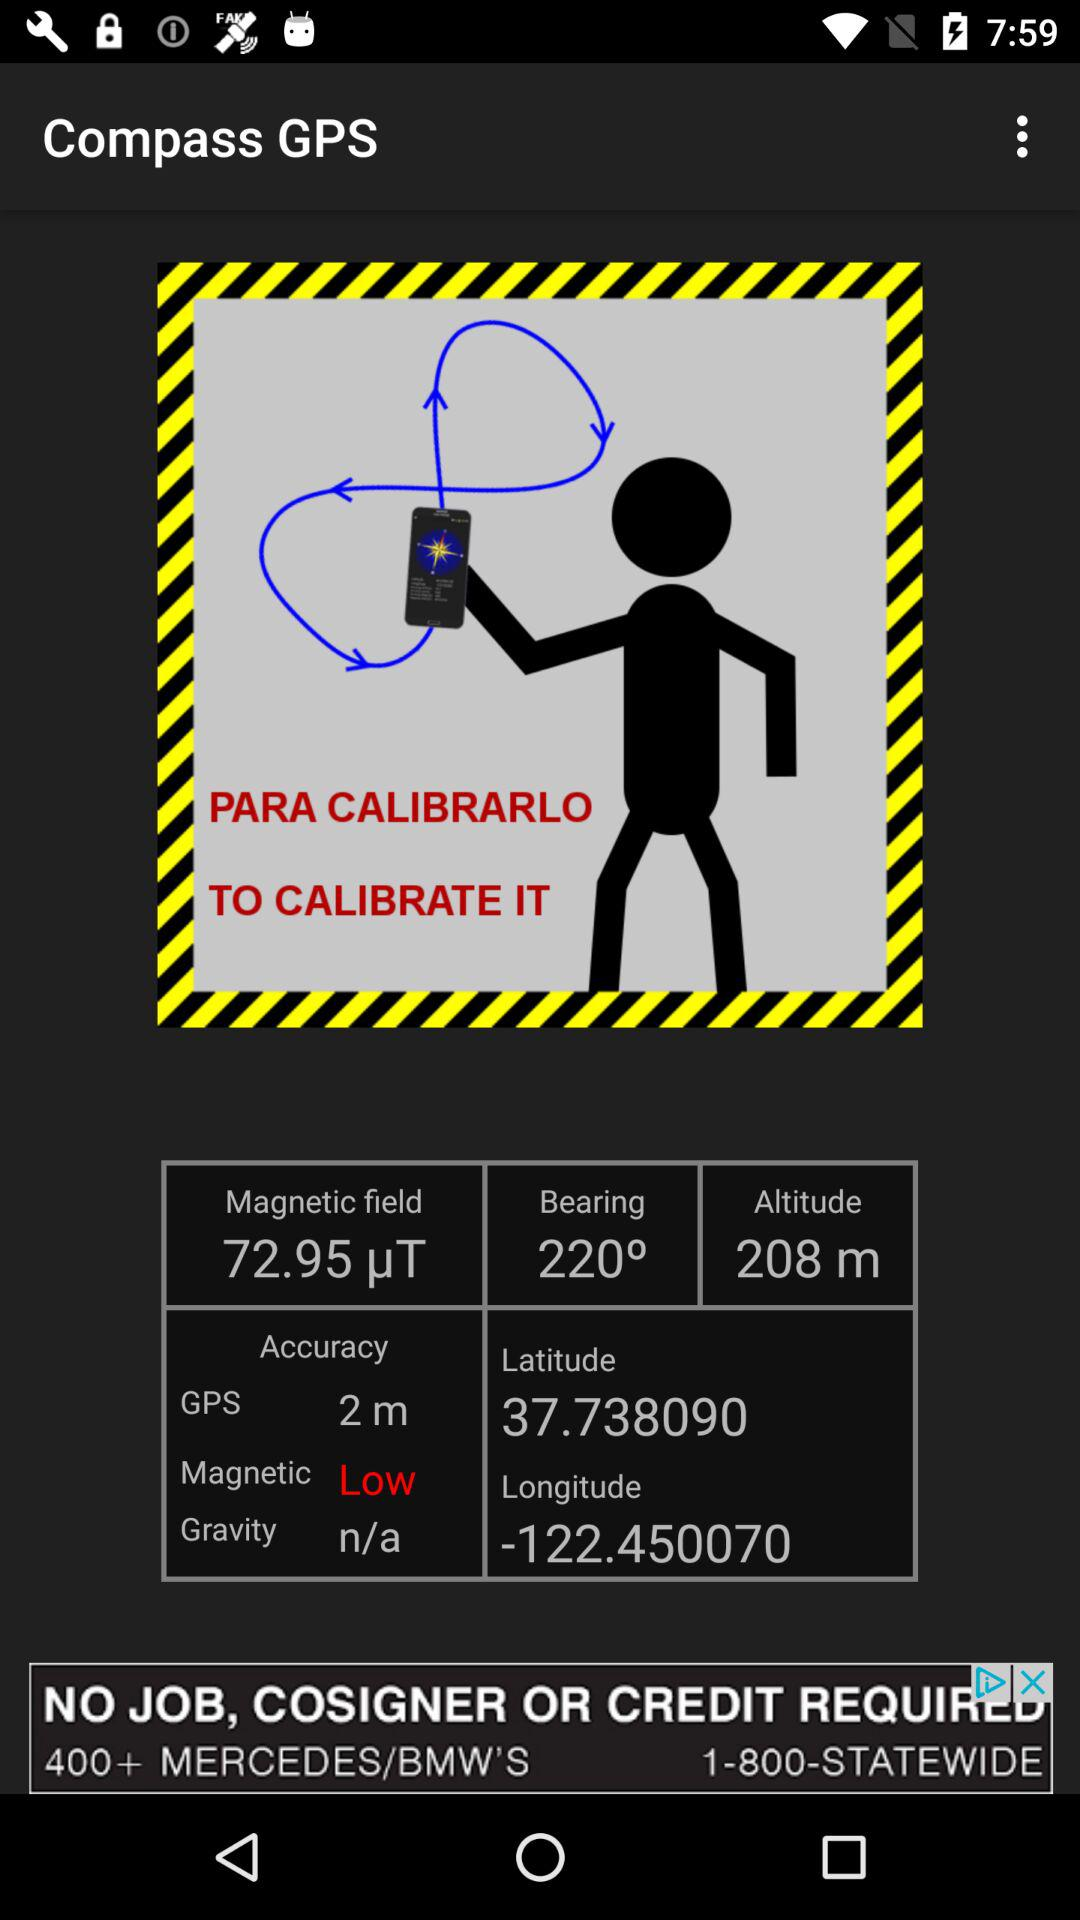In what unit is the altitude measured? The altitude is measured in meters. 